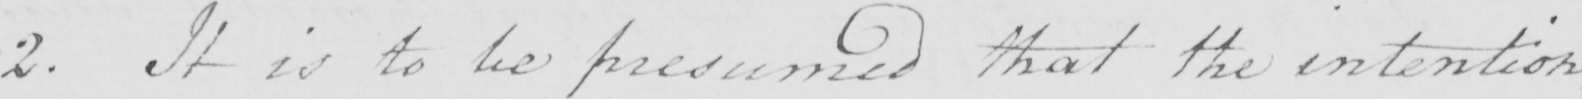What text is written in this handwritten line? 2 . It is to be presumed that the intention 